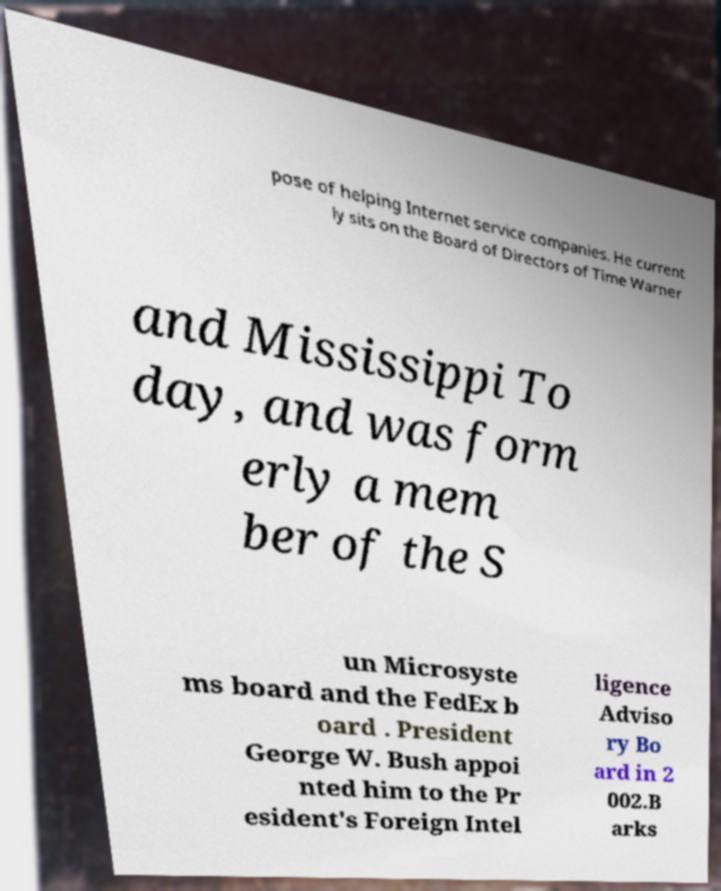Could you extract and type out the text from this image? pose of helping Internet service companies. He current ly sits on the Board of Directors of Time Warner and Mississippi To day, and was form erly a mem ber of the S un Microsyste ms board and the FedEx b oard . President George W. Bush appoi nted him to the Pr esident's Foreign Intel ligence Adviso ry Bo ard in 2 002.B arks 